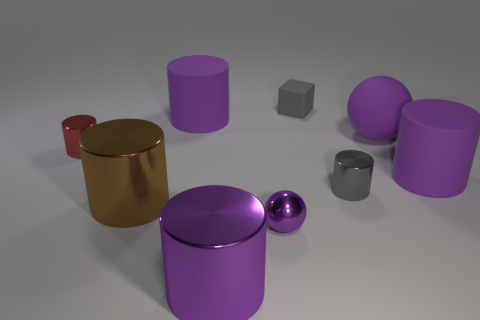Subtract all purple cylinders. How many were subtracted if there are1purple cylinders left? 2 Subtract all red spheres. How many purple cylinders are left? 3 Subtract 1 cylinders. How many cylinders are left? 5 Subtract all red cylinders. How many cylinders are left? 5 Subtract all rubber cylinders. How many cylinders are left? 4 Add 9 tiny gray metal cylinders. How many tiny gray metal cylinders are left? 10 Add 4 big cylinders. How many big cylinders exist? 8 Subtract 0 red cubes. How many objects are left? 9 Subtract all cubes. How many objects are left? 8 Subtract all yellow spheres. Subtract all blue cylinders. How many spheres are left? 2 